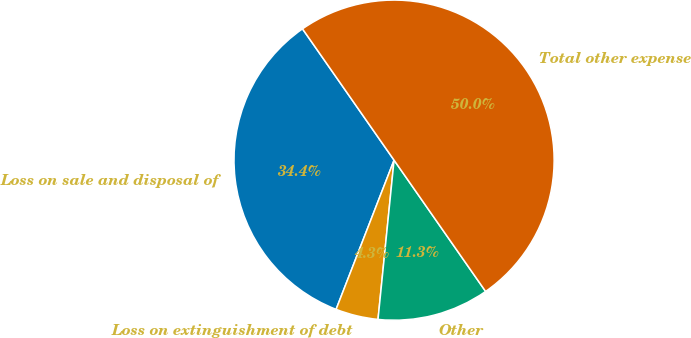Convert chart. <chart><loc_0><loc_0><loc_500><loc_500><pie_chart><fcel>Loss on sale and disposal of<fcel>Loss on extinguishment of debt<fcel>Other<fcel>Total other expense<nl><fcel>34.41%<fcel>4.3%<fcel>11.29%<fcel>50.0%<nl></chart> 